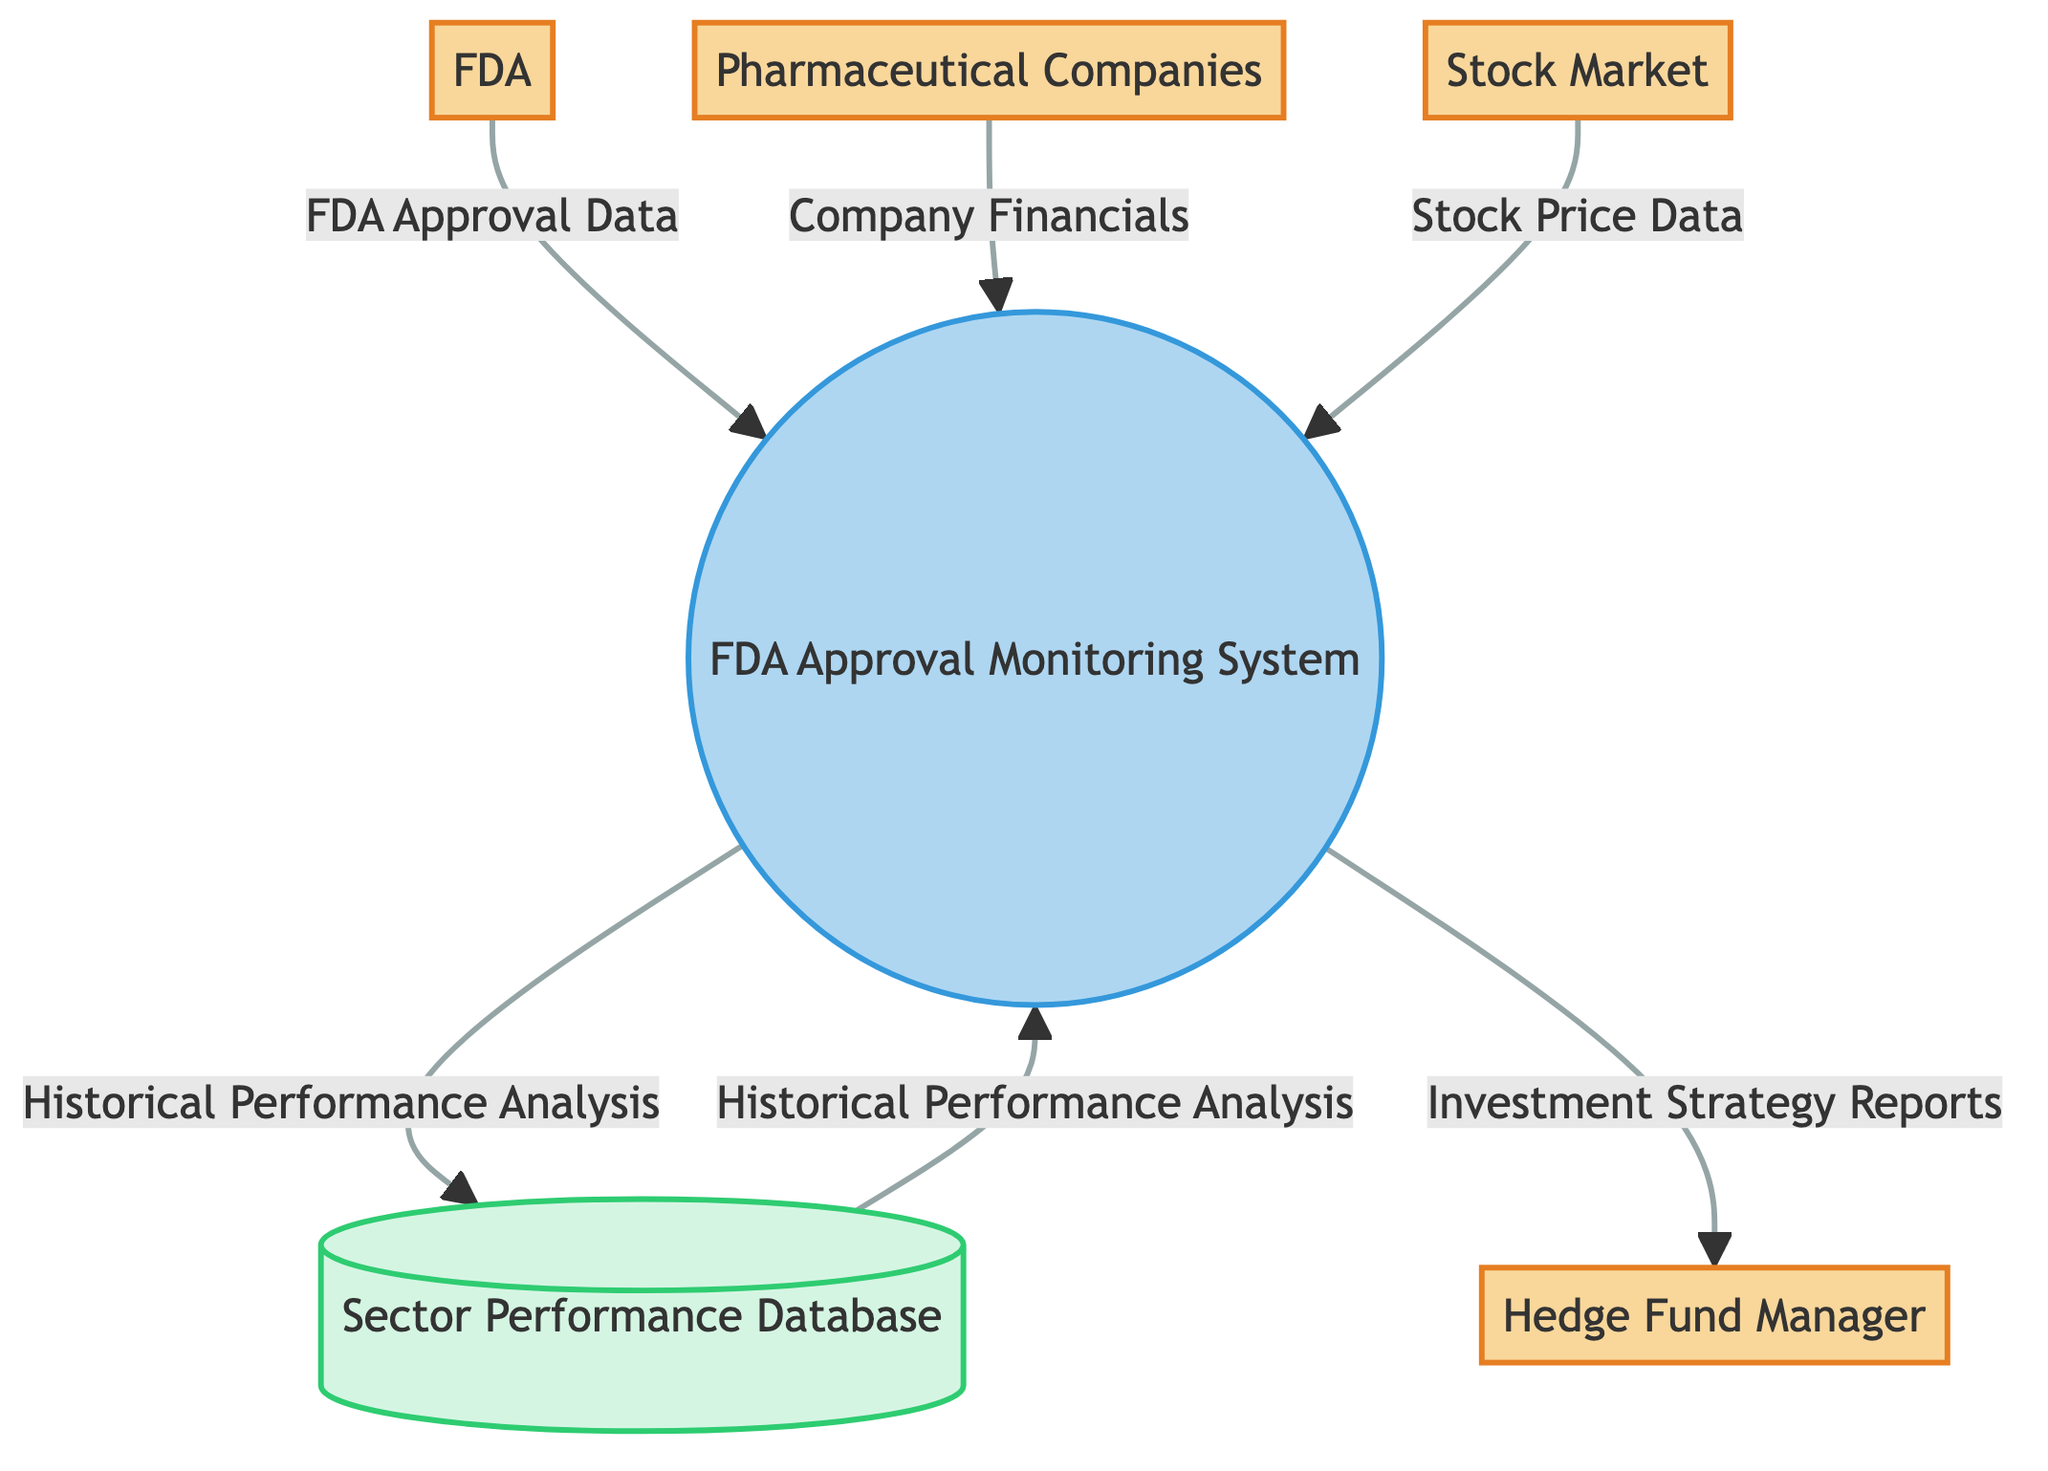What's the total number of external entities in the diagram? The diagram lists four external entities: Hedge Fund Manager, FDA, Pharmaceutical Companies, and Stock Market. Counting these entities gives a total of four.
Answer: 4 What data flows into the FDA Approval Monitoring System? The FDA Approval Monitoring System receives three data flows: FDA Approval Data from the FDA, Company Financials from Pharmaceutical Companies, and Stock Price Data from the Stock Market. Therefore, the data flows are identified as three distinct sources.
Answer: 3 What is the role of the Sector Performance Database? The Sector Performance Database stores historical and real-time data on the pharmaceutical sector's performance, which is utilized mainly for historical performance analysis. Thus, it acts as a repository for performance data.
Answer: Data Store Which external entity receives investment strategy reports directly? The Hedge Fund Manager is the external entity that receives investment strategy reports generated by the FDA Approval Monitoring System. The chart indicates a direct flow of reports to this entity.
Answer: Hedge Fund Manager How many distinct data flows exist in the diagram? The diagram indicates five distinct data flows: FDA Approval Data, Company Financials, Stock Price Data, Historical Performance Analysis, and Investment Strategy Reports. Counting all these flows gives a total of five.
Answer: 5 What external entity provides FDA Approval Data? The FDA is the external entity that provides FDA Approval Data to the FDA Approval Monitoring System, as shown in the diagram with a directed flow towards the system.
Answer: FDA What type of system is the FDA Approval Monitoring System classified as? The FDA Approval Monitoring System is classified as a process in the diagram, indicating its function in monitoring and analyzing data related to FDA approvals.
Answer: Process Which data flow is generated as an output from the FDA Approval Monitoring System? The output data flows from the FDA Approval Monitoring System are Historical Performance Analysis and Investment Strategy Reports, which are directly sent to the Sector Performance Database and Hedge Fund Manager, respectively.
Answer: Investment Strategy Reports What is the relationship between Historical Performance Analysis and Sector Performance Database? The Historical Performance Analysis is stored in the Sector Performance Database, which implies that the database receives this data flow for future reference and analysis, demonstrating a storage relationship.
Answer: Storage relationship 